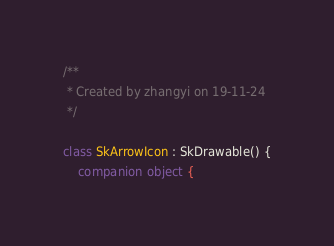Convert code to text. <code><loc_0><loc_0><loc_500><loc_500><_Kotlin_>/**
 * Created by zhangyi on 19-11-24
 */

class SkArrowIcon : SkDrawable() {
    companion object {</code> 